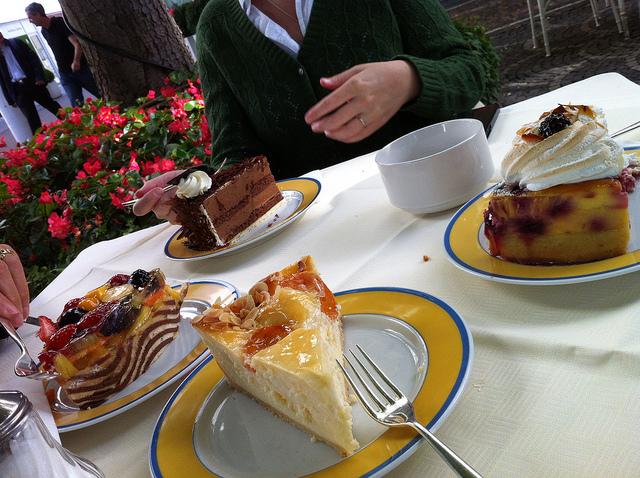What utensil are they eating the desserts with?
Answer briefly. Fork. How many deserts are shown?
Write a very short answer. 4. How many plates are on the table?
Give a very brief answer. 4. 